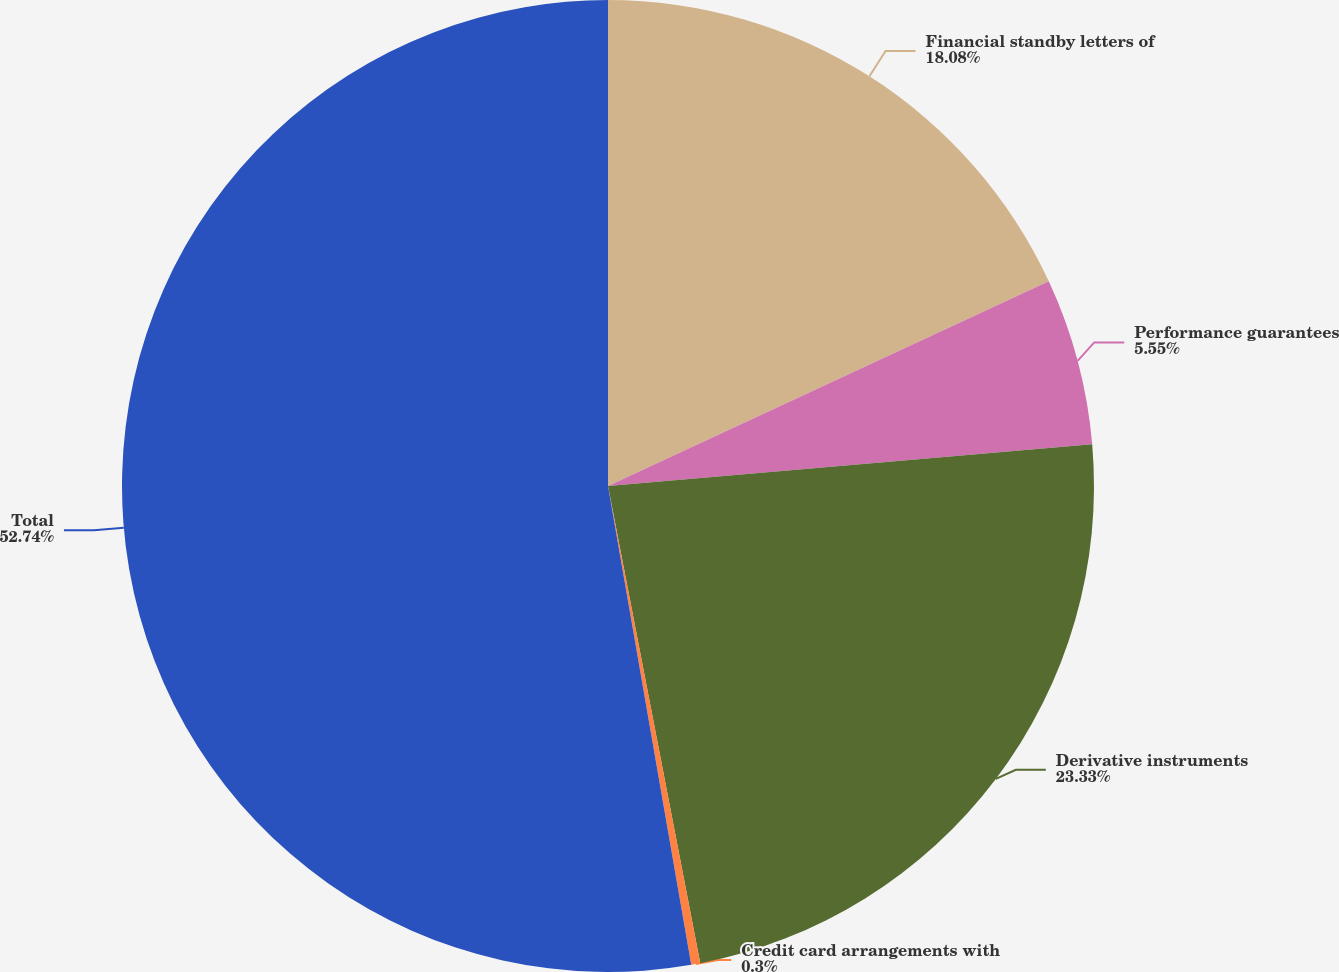Convert chart. <chart><loc_0><loc_0><loc_500><loc_500><pie_chart><fcel>Financial standby letters of<fcel>Performance guarantees<fcel>Derivative instruments<fcel>Credit card arrangements with<fcel>Total<nl><fcel>18.08%<fcel>5.55%<fcel>23.33%<fcel>0.3%<fcel>52.74%<nl></chart> 